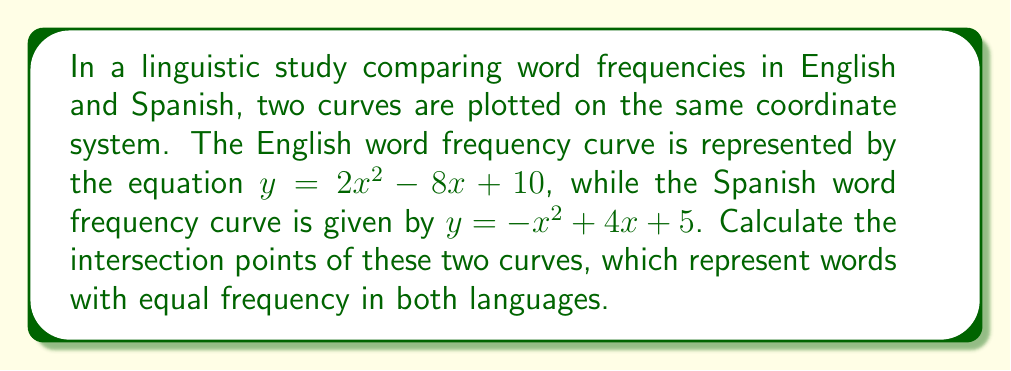Could you help me with this problem? To find the intersection points of the two curves, we need to solve the system of equations:

$$\begin{cases}
y = 2x^2 - 8x + 10 \\
y = -x^2 + 4x + 5
\end{cases}$$

Step 1: Set the equations equal to each other since they represent the same y-value at the intersection points.
$2x^2 - 8x + 10 = -x^2 + 4x + 5$

Step 2: Rearrange the equation to standard form.
$3x^2 - 12x + 5 = 0$

Step 3: Use the quadratic formula to solve for x. The quadratic formula is $x = \frac{-b \pm \sqrt{b^2 - 4ac}}{2a}$, where $a = 3$, $b = -12$, and $c = 5$.

$x = \frac{12 \pm \sqrt{(-12)^2 - 4(3)(5)}}{2(3)}$

$x = \frac{12 \pm \sqrt{144 - 60}}{6}$

$x = \frac{12 \pm \sqrt{84}}{6}$

$x = \frac{12 \pm 2\sqrt{21}}{6}$

$x = 2 \pm \frac{\sqrt{21}}{3}$

Step 4: Calculate the two x-values.
$x_1 = 2 + \frac{\sqrt{21}}{3} \approx 3.53$
$x_2 = 2 - \frac{\sqrt{21}}{3} \approx 0.47$

Step 5: Find the corresponding y-values by substituting either x-value into either of the original equations. Let's use the English curve equation:

For $x_1$: $y_1 = 2(3.53)^2 - 8(3.53) + 10 \approx 6.47$
For $x_2$: $y_2 = 2(0.47)^2 - 8(0.47) + 10 \approx 6.47$

Therefore, the intersection points are approximately (3.53, 6.47) and (0.47, 6.47).
Answer: $(2 + \frac{\sqrt{21}}{3}, 6.47)$ and $(2 - \frac{\sqrt{21}}{3}, 6.47)$ 